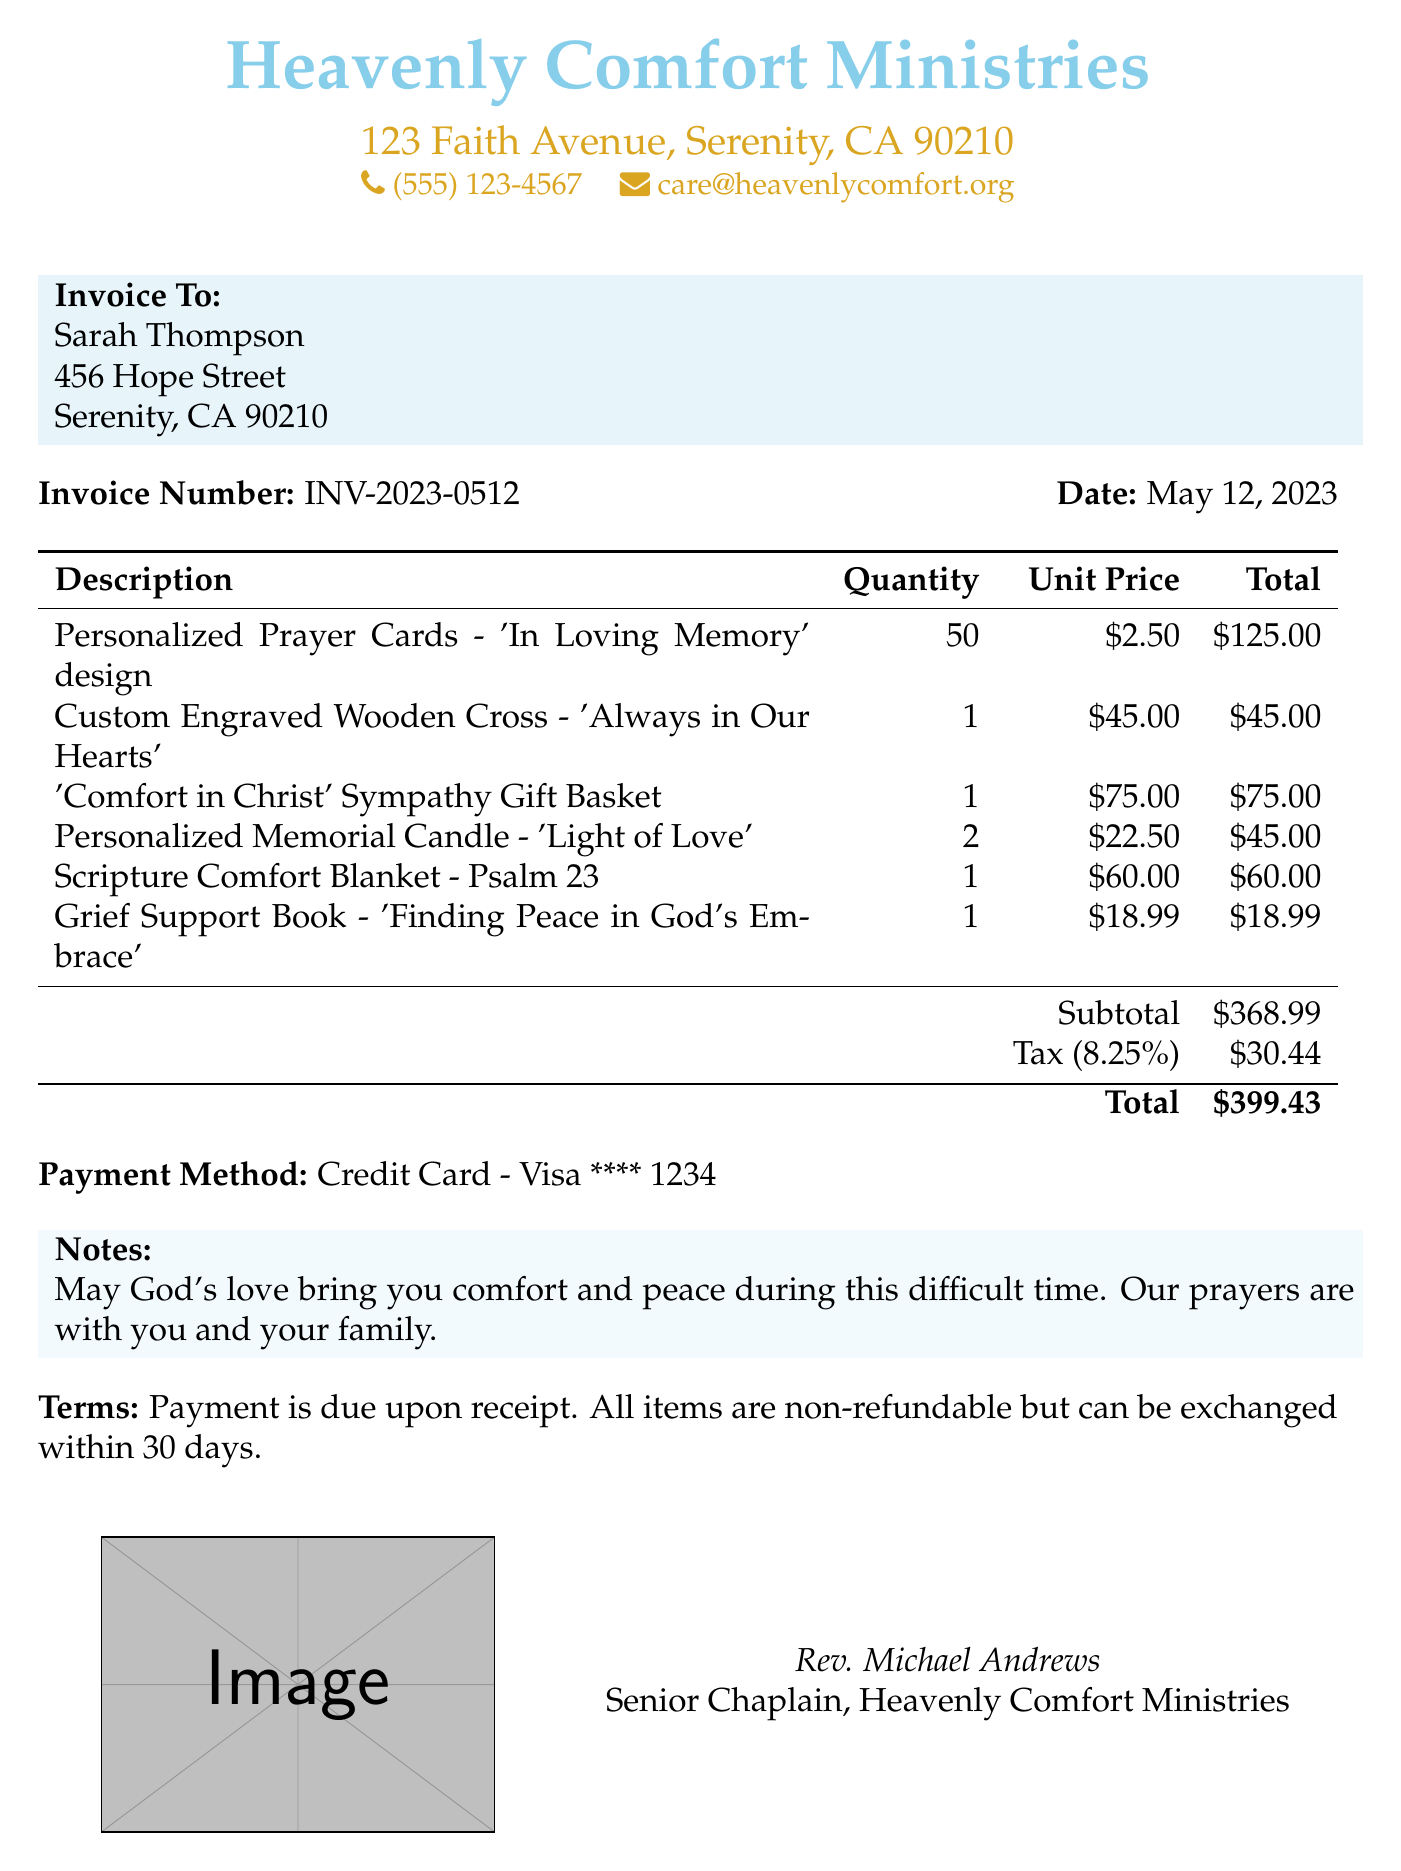What is the business name? The business name is listed at the top of the document.
Answer: Heavenly Comfort Ministries What is the invoice number? The invoice number is presented in the document as a unique identifier.
Answer: INV-2023-0512 What is the date of the invoice? The date indicates when the invoice was generated.
Answer: May 12, 2023 What is the subtotal amount? The subtotal is the total of all items before tax.
Answer: $368.99 What is the total amount after tax? The total is the sum of the subtotal and tax amount.
Answer: $399.43 How many personalized prayer cards were ordered? The quantity reflects how many prayer cards were included in the order.
Answer: 50 What is the payment method used? The payment method indicates how the transaction was processed.
Answer: Credit Card - Visa **** 1234 What is the tax rate applied? The tax rate shows the percentage of tax added to the subtotal.
Answer: 8.25% What is the name of the chaplain? The chaplain's name is provided at the end of the document.
Answer: Rev. Michael Andrews What is stated in the notes section? The notes section conveys a message to the customer during their time of grief.
Answer: May God's love bring you comfort and peace during this difficult time. Our prayers are with you and your family 